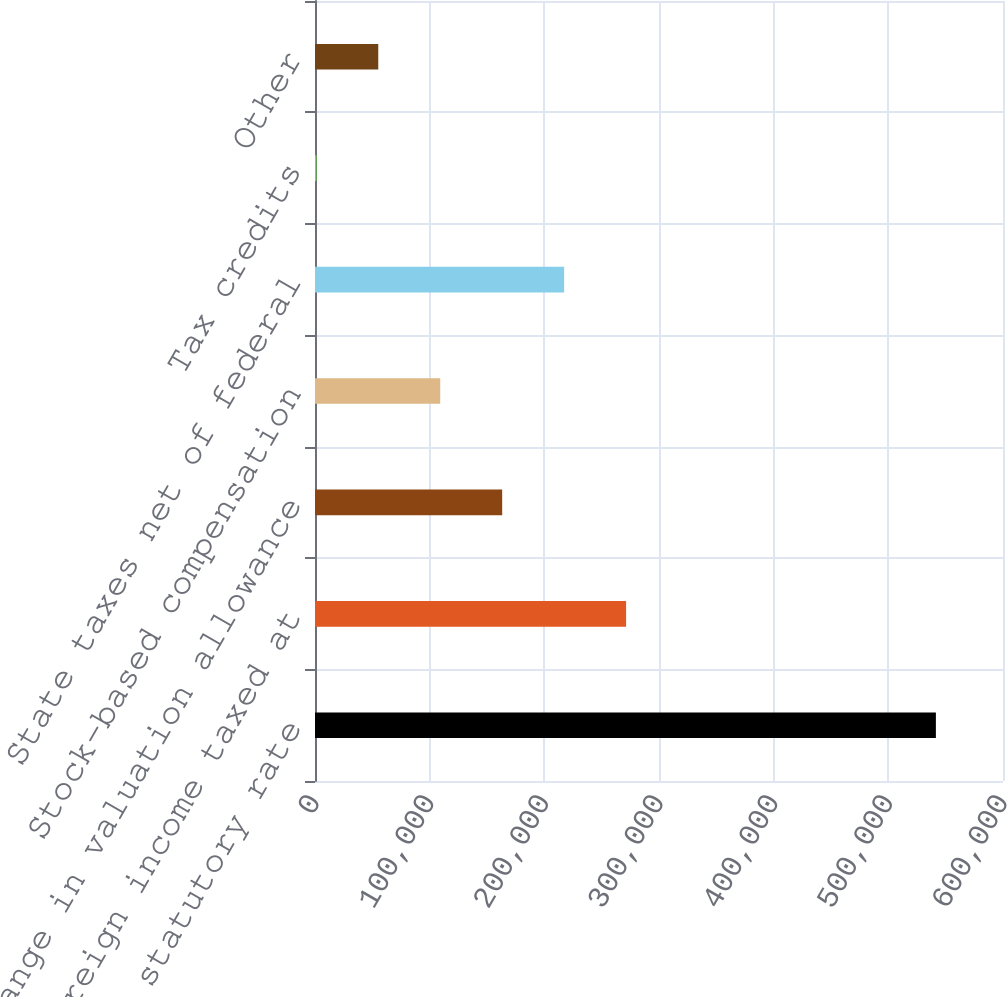Convert chart to OTSL. <chart><loc_0><loc_0><loc_500><loc_500><bar_chart><fcel>Provision at statutory rate<fcel>Foreign income taxed at<fcel>Change in valuation allowance<fcel>Stock-based compensation<fcel>State taxes net of federal<fcel>Tax credits<fcel>Other<nl><fcel>541471<fcel>271306<fcel>163241<fcel>109208<fcel>217274<fcel>1142<fcel>55174.9<nl></chart> 